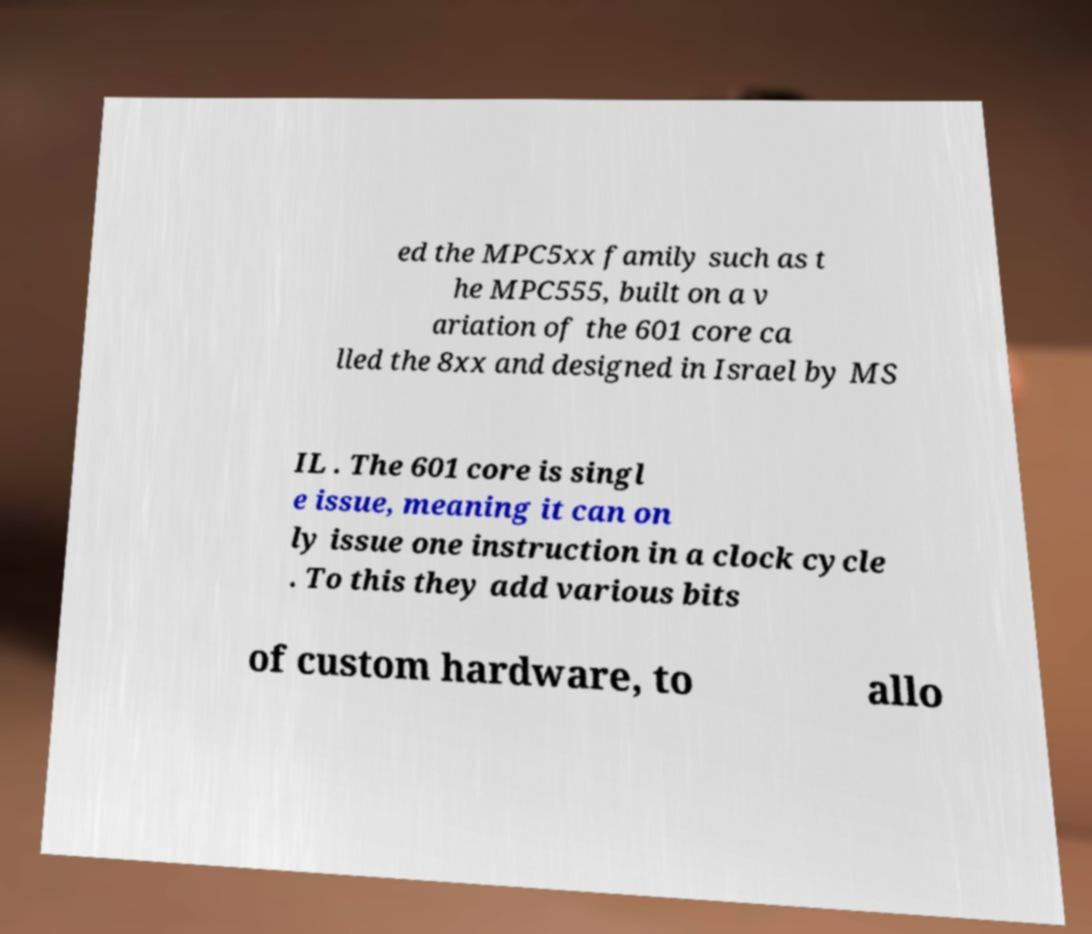Can you read and provide the text displayed in the image?This photo seems to have some interesting text. Can you extract and type it out for me? ed the MPC5xx family such as t he MPC555, built on a v ariation of the 601 core ca lled the 8xx and designed in Israel by MS IL . The 601 core is singl e issue, meaning it can on ly issue one instruction in a clock cycle . To this they add various bits of custom hardware, to allo 